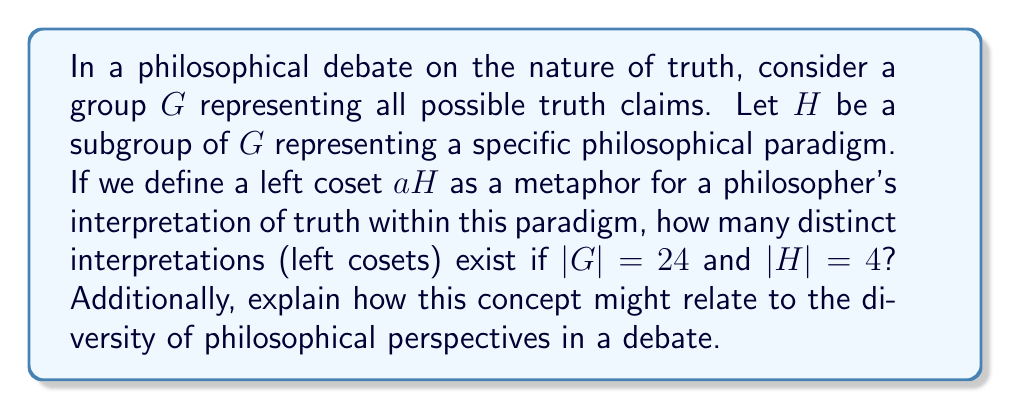What is the answer to this math problem? Let's approach this step-by-step:

1) First, recall the definition of a coset. For a group $G$ and a subgroup $H$, a left coset of $H$ in $G$ is a set of the form $aH = \{ah : h \in H\}$ for some $a \in G$.

2) A key theorem in group theory, known as Lagrange's Theorem, states that for a finite group $G$ and a subgroup $H$:

   $$|G| = |H| \cdot [G:H]$$

   where $[G:H]$ is the index of $H$ in $G$, which is equal to the number of distinct left cosets of $H$ in $G$.

3) In our case, we're given that $|G| = 24$ and $|H| = 4$. Let's substitute these values:

   $$24 = 4 \cdot [G:H]$$

4) Solving for $[G:H]$:

   $$[G:H] = 24 / 4 = 6$$

5) Therefore, there are 6 distinct left cosets of $H$ in $G$.

In the context of our philosophical metaphor:
- The group $G$ represents all possible truth claims.
- The subgroup $H$ represents a specific philosophical paradigm.
- Each left coset $aH$ represents a unique interpretation or perspective of truth within the given paradigm.
- The fact that there are 6 distinct cosets suggests that even within a single philosophical paradigm, there can be multiple interpretations or perspectives on truth.

This mathematical concept relates to philosophical debates by illustrating how a single paradigm (represented by $H$) can give rise to multiple distinct interpretations (represented by the cosets). It suggests that philosophical truth is not monolithic, but can be viewed from various angles even within a shared framework. The number of cosets (6 in this case) quantifies the diversity of perspectives possible within the given paradigm.
Answer: 6 distinct interpretations (left cosets) 